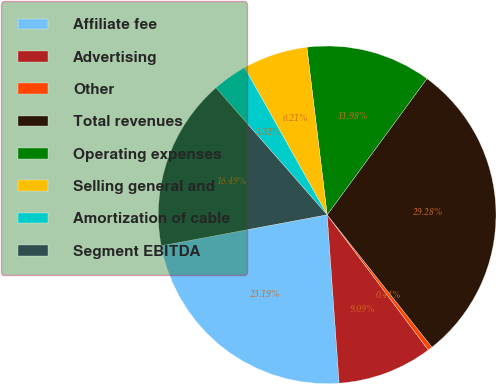<chart> <loc_0><loc_0><loc_500><loc_500><pie_chart><fcel>Affiliate fee<fcel>Advertising<fcel>Other<fcel>Total revenues<fcel>Operating expenses<fcel>Selling general and<fcel>Amortization of cable<fcel>Segment EBITDA<nl><fcel>23.19%<fcel>9.09%<fcel>0.44%<fcel>29.28%<fcel>11.98%<fcel>6.21%<fcel>3.32%<fcel>16.49%<nl></chart> 